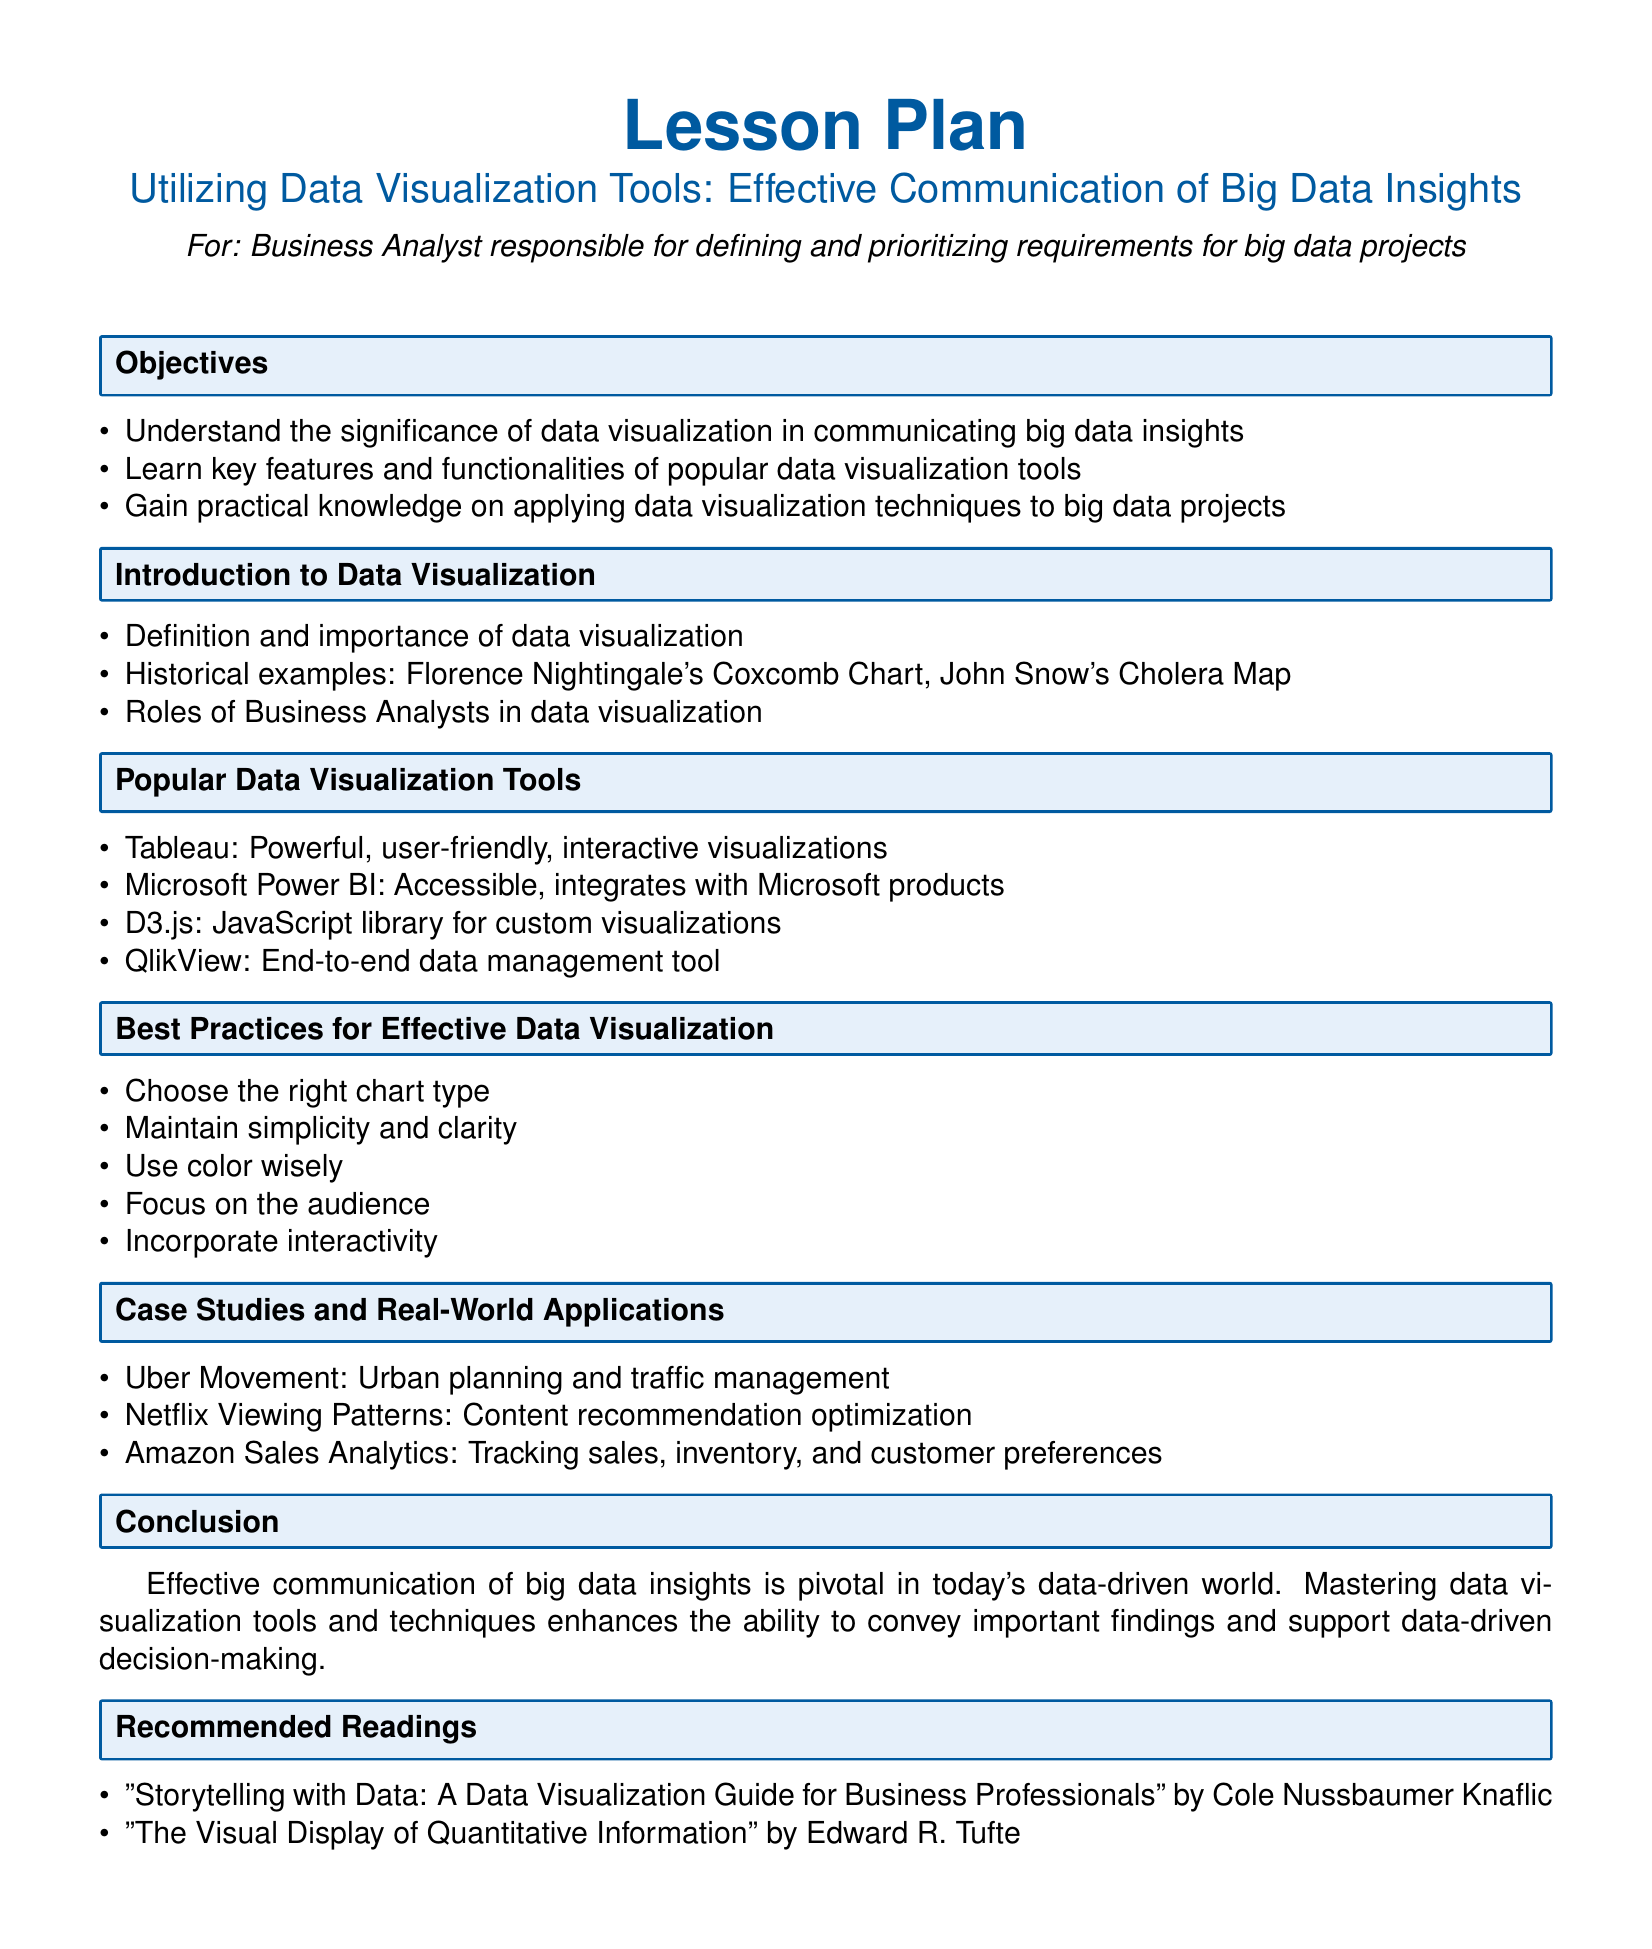What is the title of the lesson plan? The title is specified in the document's header as "Utilizing Data Visualization Tools: Effective Communication of Big Data Insights".
Answer: Utilizing Data Visualization Tools: Effective Communication of Big Data Insights Who is the target audience for this lesson plan? The document clearly states that the lesson plan is for Business Analysts responsible for defining and prioritizing requirements for big data projects.
Answer: Business Analyst Name one popular data visualization tool mentioned in the document. The document lists several tools, one of which is specifically Tableau.
Answer: Tableau What is one of the historical examples of data visualization provided? The document mentions Florence Nightingale's Coxcomb Chart as a historical example of data visualization.
Answer: Florence Nightingale's Coxcomb Chart What is the first objective of the lesson plan? The document outlines several objectives, the first being to understand the significance of data visualization in communicating big data insights.
Answer: Understand the significance of data visualization in communicating big data insights Name two best practices for effective data visualization from the document. The document outlines best practices including maintaining simplicity and clarity, and using color wisely.
Answer: Maintain simplicity and clarity; Use color wisely How many case studies are presented in the lesson plan? The document specifies three case studies and real-world applications related to data visualization.
Answer: Three What is the name of one recommended reading? The document suggests "Storytelling with Data: A Data Visualization Guide for Business Professionals" as one of the recommended readings.
Answer: Storytelling with Data: A Data Visualization Guide for Business Professionals What is the significance of data visualization according to the conclusion? The conclusion emphasizes that effective communication of big data insights is pivotal in today's data-driven world.
Answer: Pivotal in today's data-driven world 